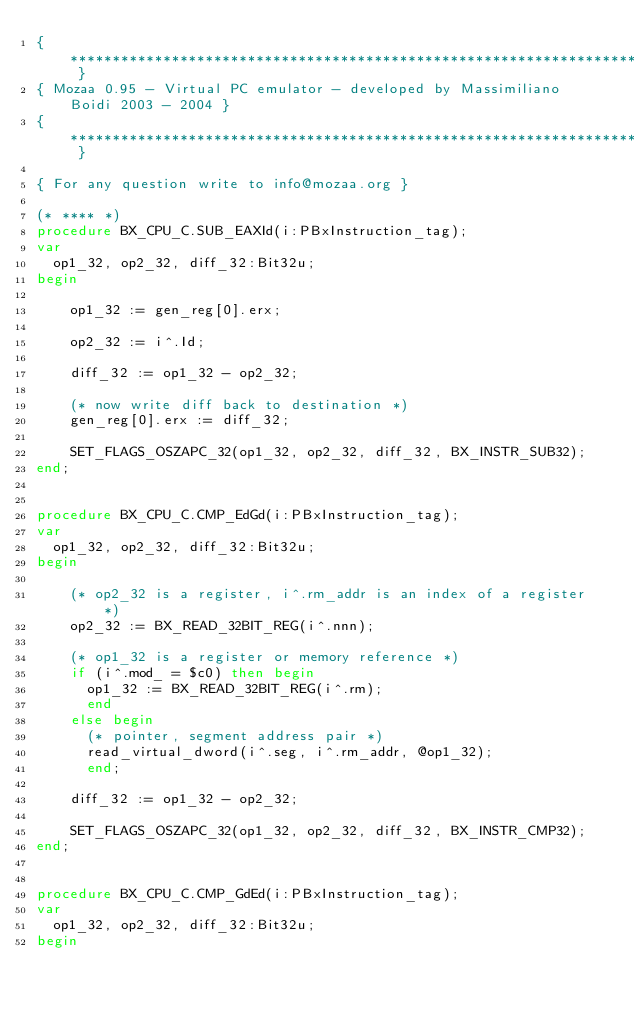Convert code to text. <code><loc_0><loc_0><loc_500><loc_500><_Pascal_>{ ****************************************************************************** }
{ Mozaa 0.95 - Virtual PC emulator - developed by Massimiliano Boidi 2003 - 2004 }
{ ****************************************************************************** }

{ For any question write to info@mozaa.org }

(* **** *)
procedure BX_CPU_C.SUB_EAXId(i:PBxInstruction_tag);
var
  op1_32, op2_32, diff_32:Bit32u;
begin

    op1_32 := gen_reg[0].erx;

    op2_32 := i^.Id;

    diff_32 := op1_32 - op2_32;

    (* now write diff back to destination *)
    gen_reg[0].erx := diff_32;

    SET_FLAGS_OSZAPC_32(op1_32, op2_32, diff_32, BX_INSTR_SUB32);
end;


procedure BX_CPU_C.CMP_EdGd(i:PBxInstruction_tag);
var
  op1_32, op2_32, diff_32:Bit32u;
begin

    (* op2_32 is a register, i^.rm_addr is an index of a register *)
    op2_32 := BX_READ_32BIT_REG(i^.nnn);

    (* op1_32 is a register or memory reference *)
    if (i^.mod_ = $c0) then begin
      op1_32 := BX_READ_32BIT_REG(i^.rm);
      end
    else begin
      (* pointer, segment address pair *)
      read_virtual_dword(i^.seg, i^.rm_addr, @op1_32);
      end;

    diff_32 := op1_32 - op2_32;

    SET_FLAGS_OSZAPC_32(op1_32, op2_32, diff_32, BX_INSTR_CMP32);
end;


procedure BX_CPU_C.CMP_GdEd(i:PBxInstruction_tag);
var
  op1_32, op2_32, diff_32:Bit32u;
begin
</code> 